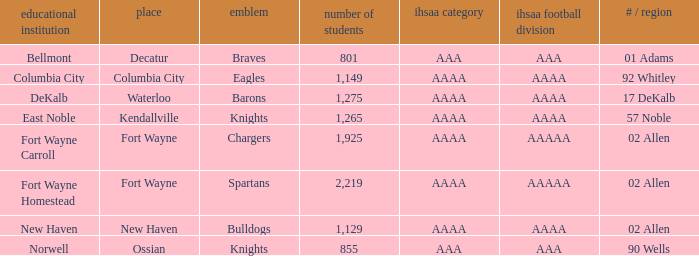What's the enrollment for Kendallville? 1265.0. 